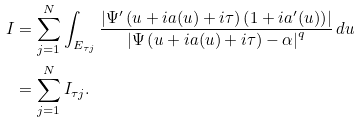Convert formula to latex. <formula><loc_0><loc_0><loc_500><loc_500>I & = \sum _ { j = 1 } ^ { N } \int _ { E _ { \tau j } } \frac { \left | \Psi ^ { \prime } \left ( u + i a ( u ) + i \tau \right ) \left ( 1 + i a ^ { \prime } ( u ) \right ) \right | } { \left | \Psi \left ( u + i a ( u ) + i \tau \right ) - \alpha \right | ^ { q } } \, d u \\ & = \sum _ { j = 1 } ^ { N } I _ { \tau j } .</formula> 